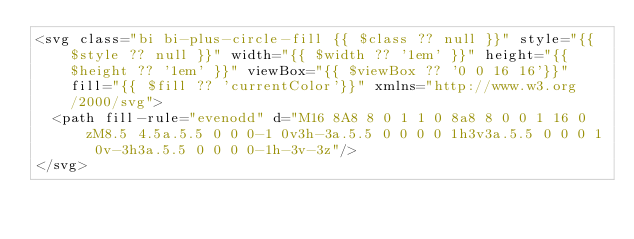Convert code to text. <code><loc_0><loc_0><loc_500><loc_500><_PHP_><svg class="bi bi-plus-circle-fill {{ $class ?? null }}" style="{{ $style ?? null }}" width="{{ $width ?? '1em' }}" height="{{ $height ?? '1em' }}" viewBox="{{ $viewBox ?? '0 0 16 16'}}" fill="{{ $fill ?? 'currentColor'}}" xmlns="http://www.w3.org/2000/svg">
  <path fill-rule="evenodd" d="M16 8A8 8 0 1 1 0 8a8 8 0 0 1 16 0zM8.5 4.5a.5.5 0 0 0-1 0v3h-3a.5.5 0 0 0 0 1h3v3a.5.5 0 0 0 1 0v-3h3a.5.5 0 0 0 0-1h-3v-3z"/>
</svg>
</code> 